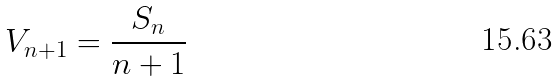Convert formula to latex. <formula><loc_0><loc_0><loc_500><loc_500>V _ { n + 1 } = \frac { S _ { n } } { n + 1 }</formula> 